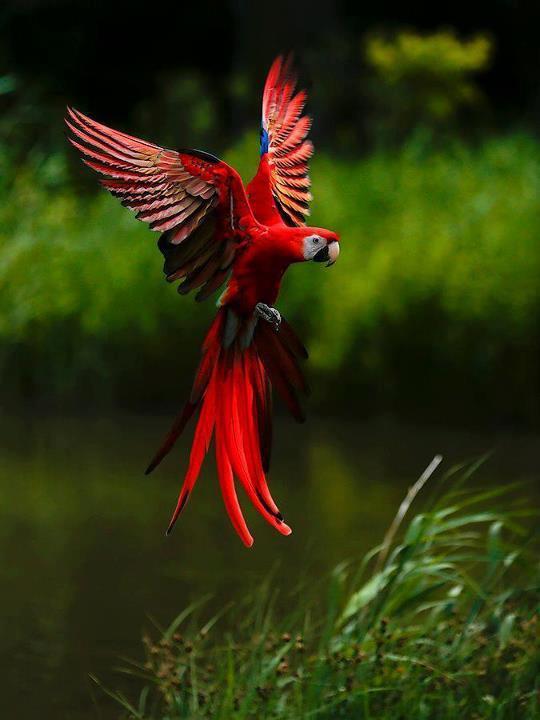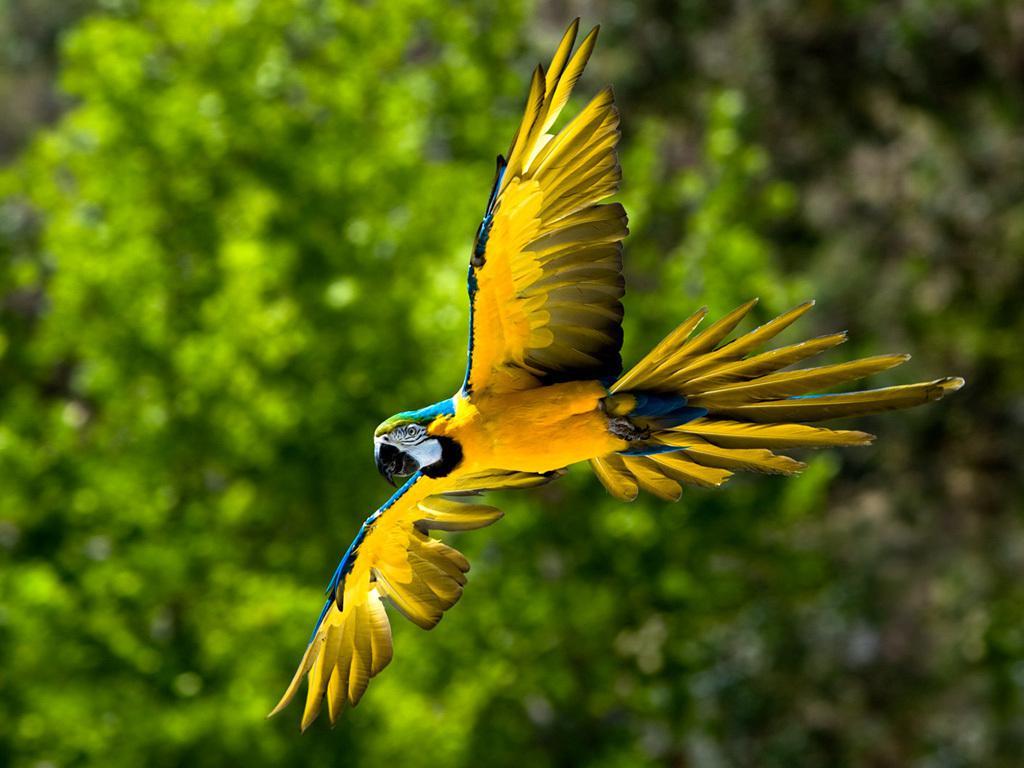The first image is the image on the left, the second image is the image on the right. Given the left and right images, does the statement "In the paired images, only parrots with spread wings are shown." hold true? Answer yes or no. Yes. 